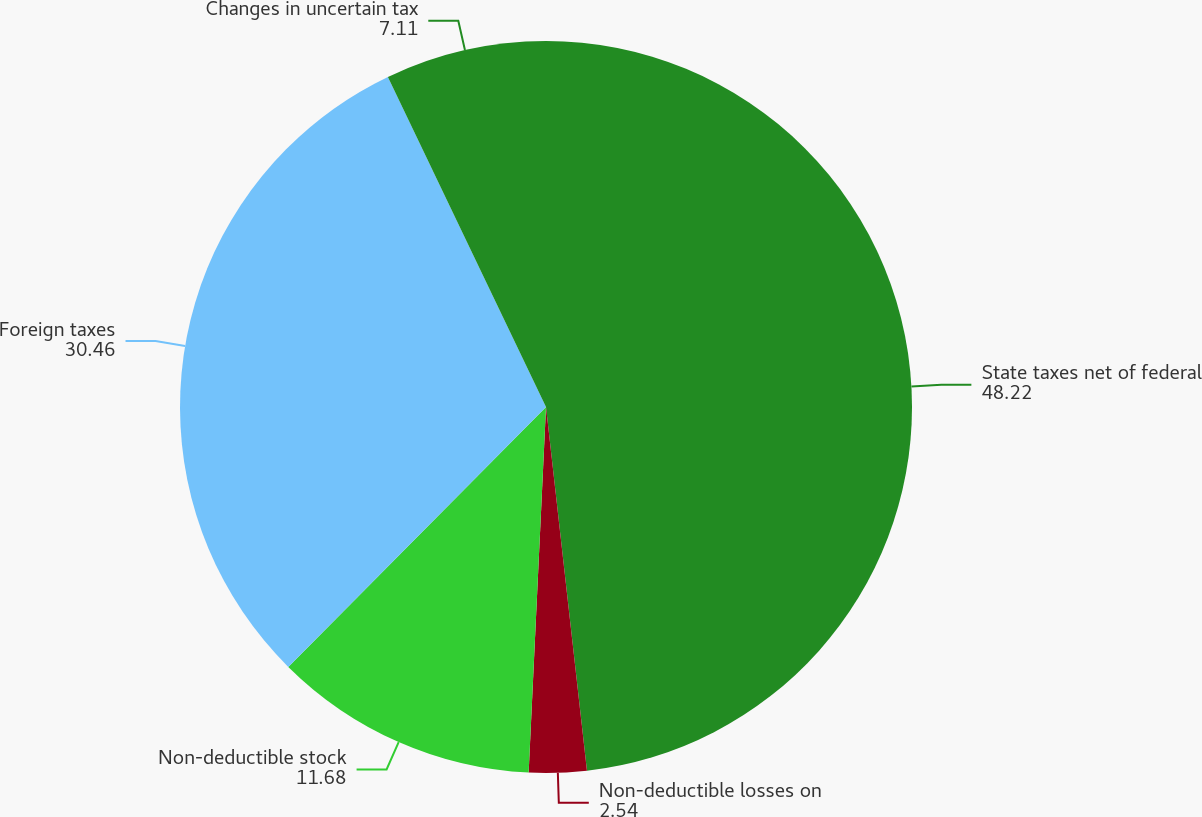<chart> <loc_0><loc_0><loc_500><loc_500><pie_chart><fcel>State taxes net of federal<fcel>Non-deductible losses on<fcel>Non-deductible stock<fcel>Foreign taxes<fcel>Changes in uncertain tax<nl><fcel>48.22%<fcel>2.54%<fcel>11.68%<fcel>30.46%<fcel>7.11%<nl></chart> 